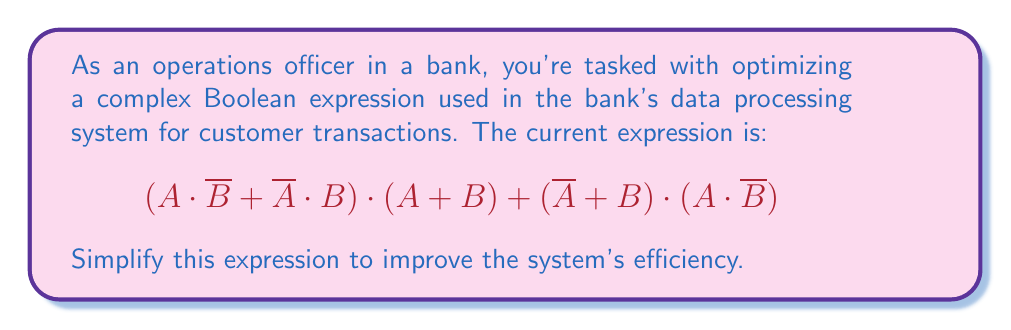Teach me how to tackle this problem. Let's simplify this expression step by step:

1) First, let's focus on the left part: $(A \cdot \overline{B} + \overline{A} \cdot B) \cdot (A + B)$
   This is the XOR operation $(A \oplus B)$ multiplied by $(A + B)$

2) The right part: $(\overline{A} + B) \cdot (A \cdot \overline{B})$
   This can be simplified using the distributive property:
   $(\overline{A} \cdot A \cdot \overline{B}) + (B \cdot A \cdot \overline{B})$
   $\overline{A} \cdot A = 0$, so this whole term becomes 0

3) Now our expression is: $(A \oplus B) \cdot (A + B) + 0$
   Which is simply: $(A \oplus B) \cdot (A + B)$

4) Expanding this:
   $(A \cdot \overline{B} + \overline{A} \cdot B) \cdot (A + B)$
   $= (A \cdot \overline{B} \cdot A) + (A \cdot \overline{B} \cdot B) + (\overline{A} \cdot B \cdot A) + (\overline{A} \cdot B \cdot B)$

5) Simplify:
   $A \cdot \overline{B} \cdot A = A \cdot \overline{B}$
   $A \cdot \overline{B} \cdot B = 0$
   $\overline{A} \cdot B \cdot A = 0$
   $\overline{A} \cdot B \cdot B = \overline{A} \cdot B$

6) Our expression becomes:
   $A \cdot \overline{B} + \overline{A} \cdot B$

7) This is the definition of XOR $(A \oplus B)$

Therefore, the simplified expression is $A \oplus B$.
Answer: $A \oplus B$ 